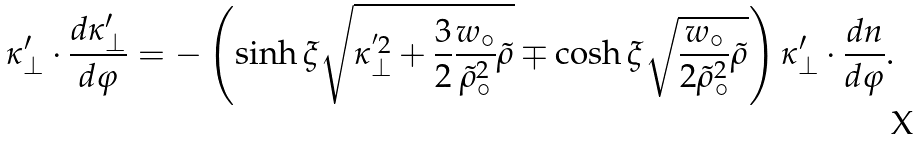Convert formula to latex. <formula><loc_0><loc_0><loc_500><loc_500>\kappa ^ { \prime } _ { \perp } \cdot \frac { d \kappa ^ { \prime } _ { \perp } } { d \varphi } = - \left ( \sinh \xi \sqrt { \kappa _ { \perp } ^ { ^ { \prime } 2 } + \frac { 3 } { 2 } \frac { w _ { \circ } } { \tilde { \rho } ^ { 2 } _ { \circ } } \tilde { \rho } } \mp \cosh \xi \sqrt { \frac { w _ { \circ } } { 2 \tilde { \rho } ^ { 2 } _ { \circ } } \tilde { \rho } } \right ) \kappa ^ { \prime } _ { \perp } \cdot \frac { d n } { d \varphi } .</formula> 